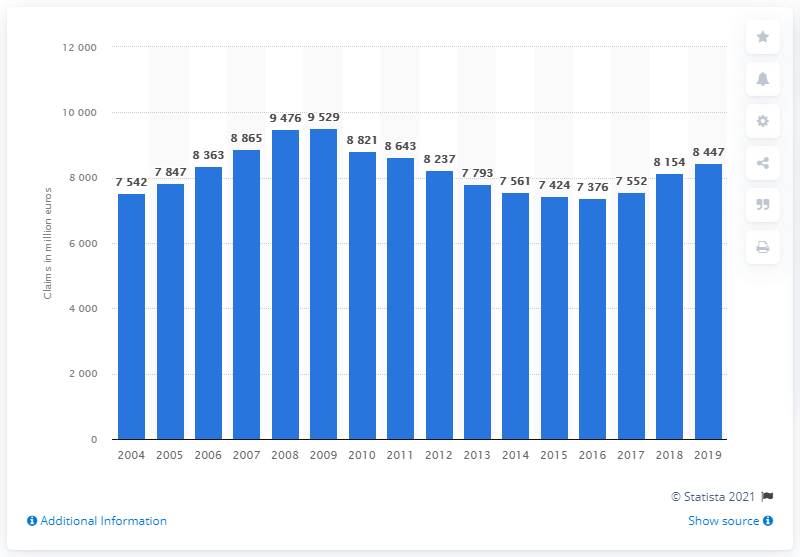List a handful of essential elements in this visual. In 2009, the value of motor claims paid in Spain was 9,529. The total worth of motor insurance claims paid out by insurers in Spain in 2018 was 8,447. In 2009, the value of motor claims paid on the insurance market in Spain reached a peak. 